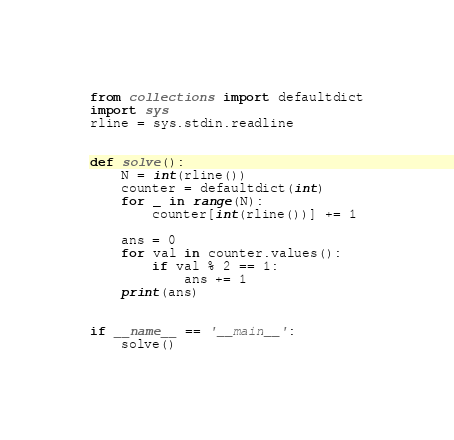Convert code to text. <code><loc_0><loc_0><loc_500><loc_500><_Python_>from collections import defaultdict
import sys
rline = sys.stdin.readline


def solve():
    N = int(rline())
    counter = defaultdict(int)
    for _ in range(N):
        counter[int(rline())] += 1
    
    ans = 0
    for val in counter.values():
        if val % 2 == 1:
            ans += 1
    print(ans)


if __name__ == '__main__':
    solve()
</code> 